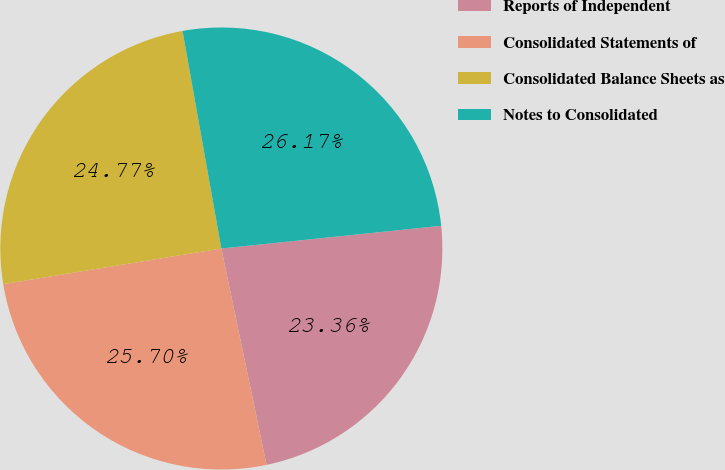Convert chart to OTSL. <chart><loc_0><loc_0><loc_500><loc_500><pie_chart><fcel>Reports of Independent<fcel>Consolidated Statements of<fcel>Consolidated Balance Sheets as<fcel>Notes to Consolidated<nl><fcel>23.36%<fcel>25.7%<fcel>24.77%<fcel>26.17%<nl></chart> 